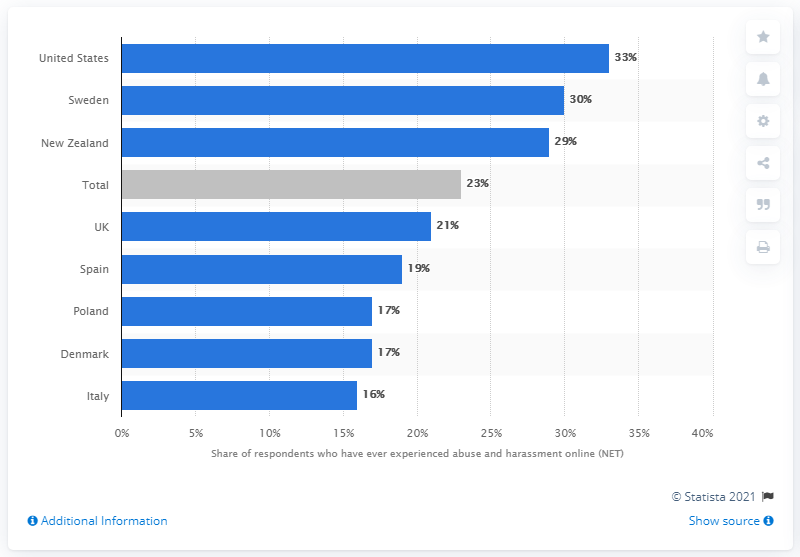Indicate a few pertinent items in this graphic. The country with the lowest victimization rate was Italy. In the United States, the victimization rate was 33.. 